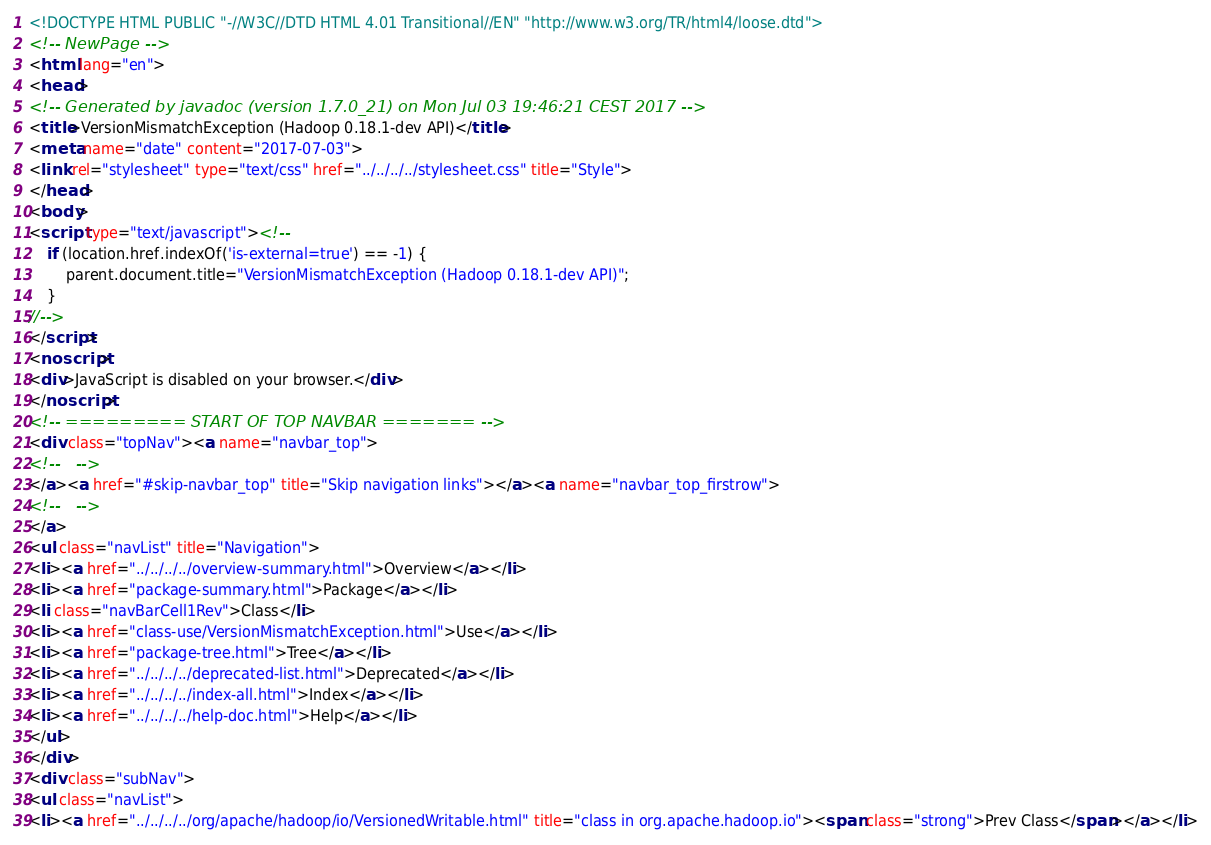<code> <loc_0><loc_0><loc_500><loc_500><_HTML_><!DOCTYPE HTML PUBLIC "-//W3C//DTD HTML 4.01 Transitional//EN" "http://www.w3.org/TR/html4/loose.dtd">
<!-- NewPage -->
<html lang="en">
<head>
<!-- Generated by javadoc (version 1.7.0_21) on Mon Jul 03 19:46:21 CEST 2017 -->
<title>VersionMismatchException (Hadoop 0.18.1-dev API)</title>
<meta name="date" content="2017-07-03">
<link rel="stylesheet" type="text/css" href="../../../../stylesheet.css" title="Style">
</head>
<body>
<script type="text/javascript"><!--
    if (location.href.indexOf('is-external=true') == -1) {
        parent.document.title="VersionMismatchException (Hadoop 0.18.1-dev API)";
    }
//-->
</script>
<noscript>
<div>JavaScript is disabled on your browser.</div>
</noscript>
<!-- ========= START OF TOP NAVBAR ======= -->
<div class="topNav"><a name="navbar_top">
<!--   -->
</a><a href="#skip-navbar_top" title="Skip navigation links"></a><a name="navbar_top_firstrow">
<!--   -->
</a>
<ul class="navList" title="Navigation">
<li><a href="../../../../overview-summary.html">Overview</a></li>
<li><a href="package-summary.html">Package</a></li>
<li class="navBarCell1Rev">Class</li>
<li><a href="class-use/VersionMismatchException.html">Use</a></li>
<li><a href="package-tree.html">Tree</a></li>
<li><a href="../../../../deprecated-list.html">Deprecated</a></li>
<li><a href="../../../../index-all.html">Index</a></li>
<li><a href="../../../../help-doc.html">Help</a></li>
</ul>
</div>
<div class="subNav">
<ul class="navList">
<li><a href="../../../../org/apache/hadoop/io/VersionedWritable.html" title="class in org.apache.hadoop.io"><span class="strong">Prev Class</span></a></li></code> 